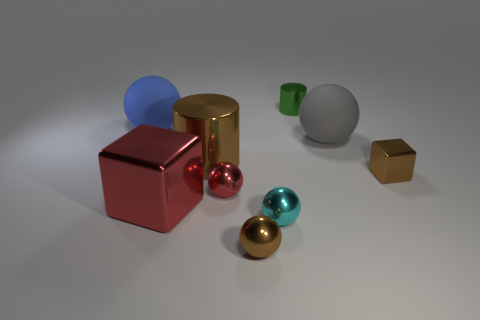Add 1 big red blocks. How many objects exist? 10 Subtract all cylinders. How many objects are left? 7 Subtract all big red things. Subtract all tiny green metal things. How many objects are left? 7 Add 5 big brown metal objects. How many big brown metal objects are left? 6 Add 2 brown metallic cylinders. How many brown metallic cylinders exist? 3 Subtract 0 purple blocks. How many objects are left? 9 